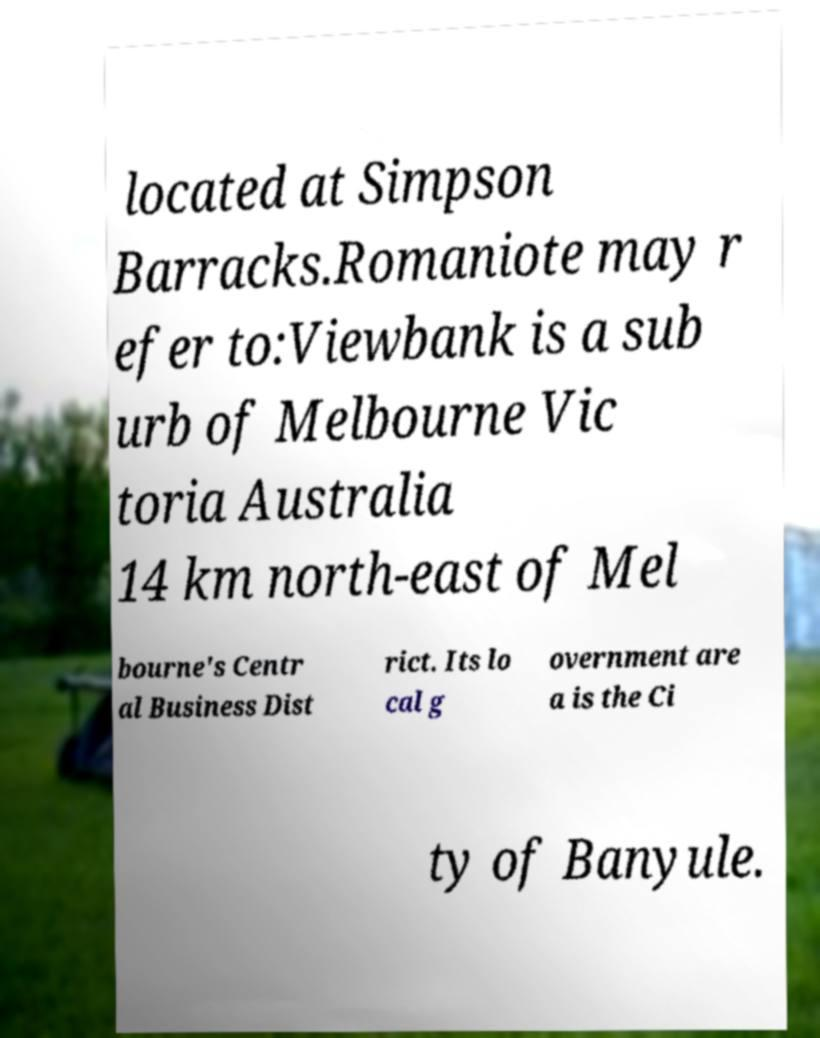Can you read and provide the text displayed in the image?This photo seems to have some interesting text. Can you extract and type it out for me? located at Simpson Barracks.Romaniote may r efer to:Viewbank is a sub urb of Melbourne Vic toria Australia 14 km north-east of Mel bourne's Centr al Business Dist rict. Its lo cal g overnment are a is the Ci ty of Banyule. 